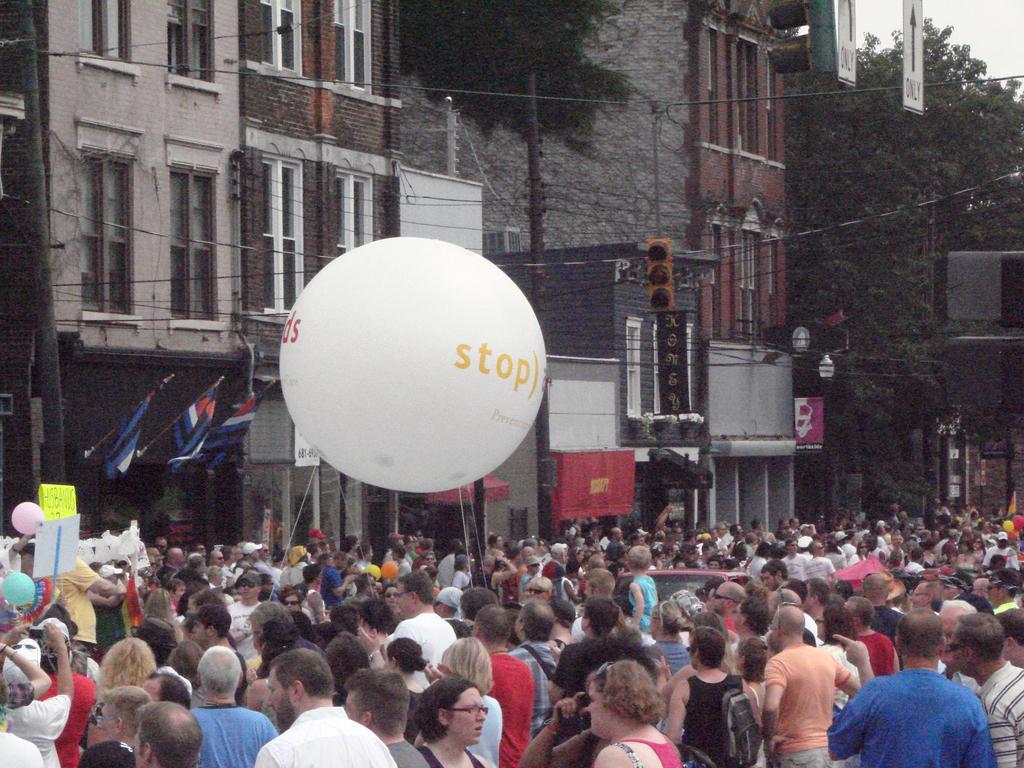In one or two sentences, can you explain what this image depicts? In this image in front there are people. There are balloons, flags. There is a light pole. There are traffic lights, poles. In the background of the image there are trees, buildings, directional boards. At the top of the image there is sky. 